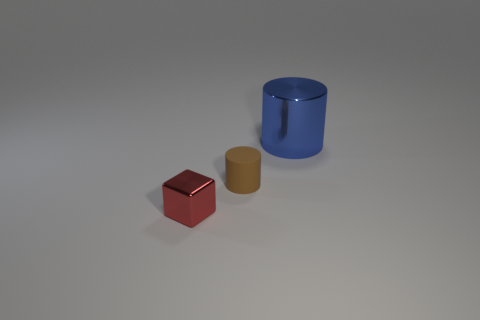Is there anything else that has the same material as the brown object?
Make the answer very short. No. There is a tiny thing to the right of the small object left of the small brown matte thing; how many big blue things are in front of it?
Ensure brevity in your answer.  0. There is a big blue thing; what number of small shiny cubes are in front of it?
Your answer should be very brief. 1. What number of brown cylinders have the same material as the blue thing?
Provide a succinct answer. 0. The other object that is made of the same material as the large blue object is what color?
Offer a terse response. Red. What material is the tiny object that is behind the metal thing left of the cylinder left of the metallic cylinder?
Make the answer very short. Rubber. Does the metallic thing right of the red block have the same size as the tiny brown rubber cylinder?
Make the answer very short. No. How many big objects are either red rubber things or cubes?
Your response must be concise. 0. Is there another matte cylinder that has the same color as the large cylinder?
Make the answer very short. No. There is a brown matte object that is the same size as the red thing; what is its shape?
Offer a very short reply. Cylinder. 